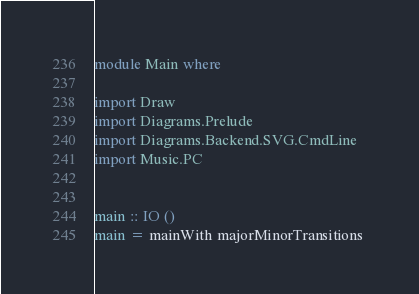<code> <loc_0><loc_0><loc_500><loc_500><_Haskell_>module Main where

import Draw
import Diagrams.Prelude
import Diagrams.Backend.SVG.CmdLine
import Music.PC


main :: IO ()
main = mainWith majorMinorTransitions 
</code> 